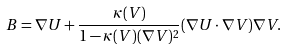<formula> <loc_0><loc_0><loc_500><loc_500>B = \nabla U + \frac { \kappa ( V ) } { 1 - \kappa ( V ) ( \nabla V ) ^ { 2 } } ( \nabla U \cdot \nabla V ) \nabla V .</formula> 